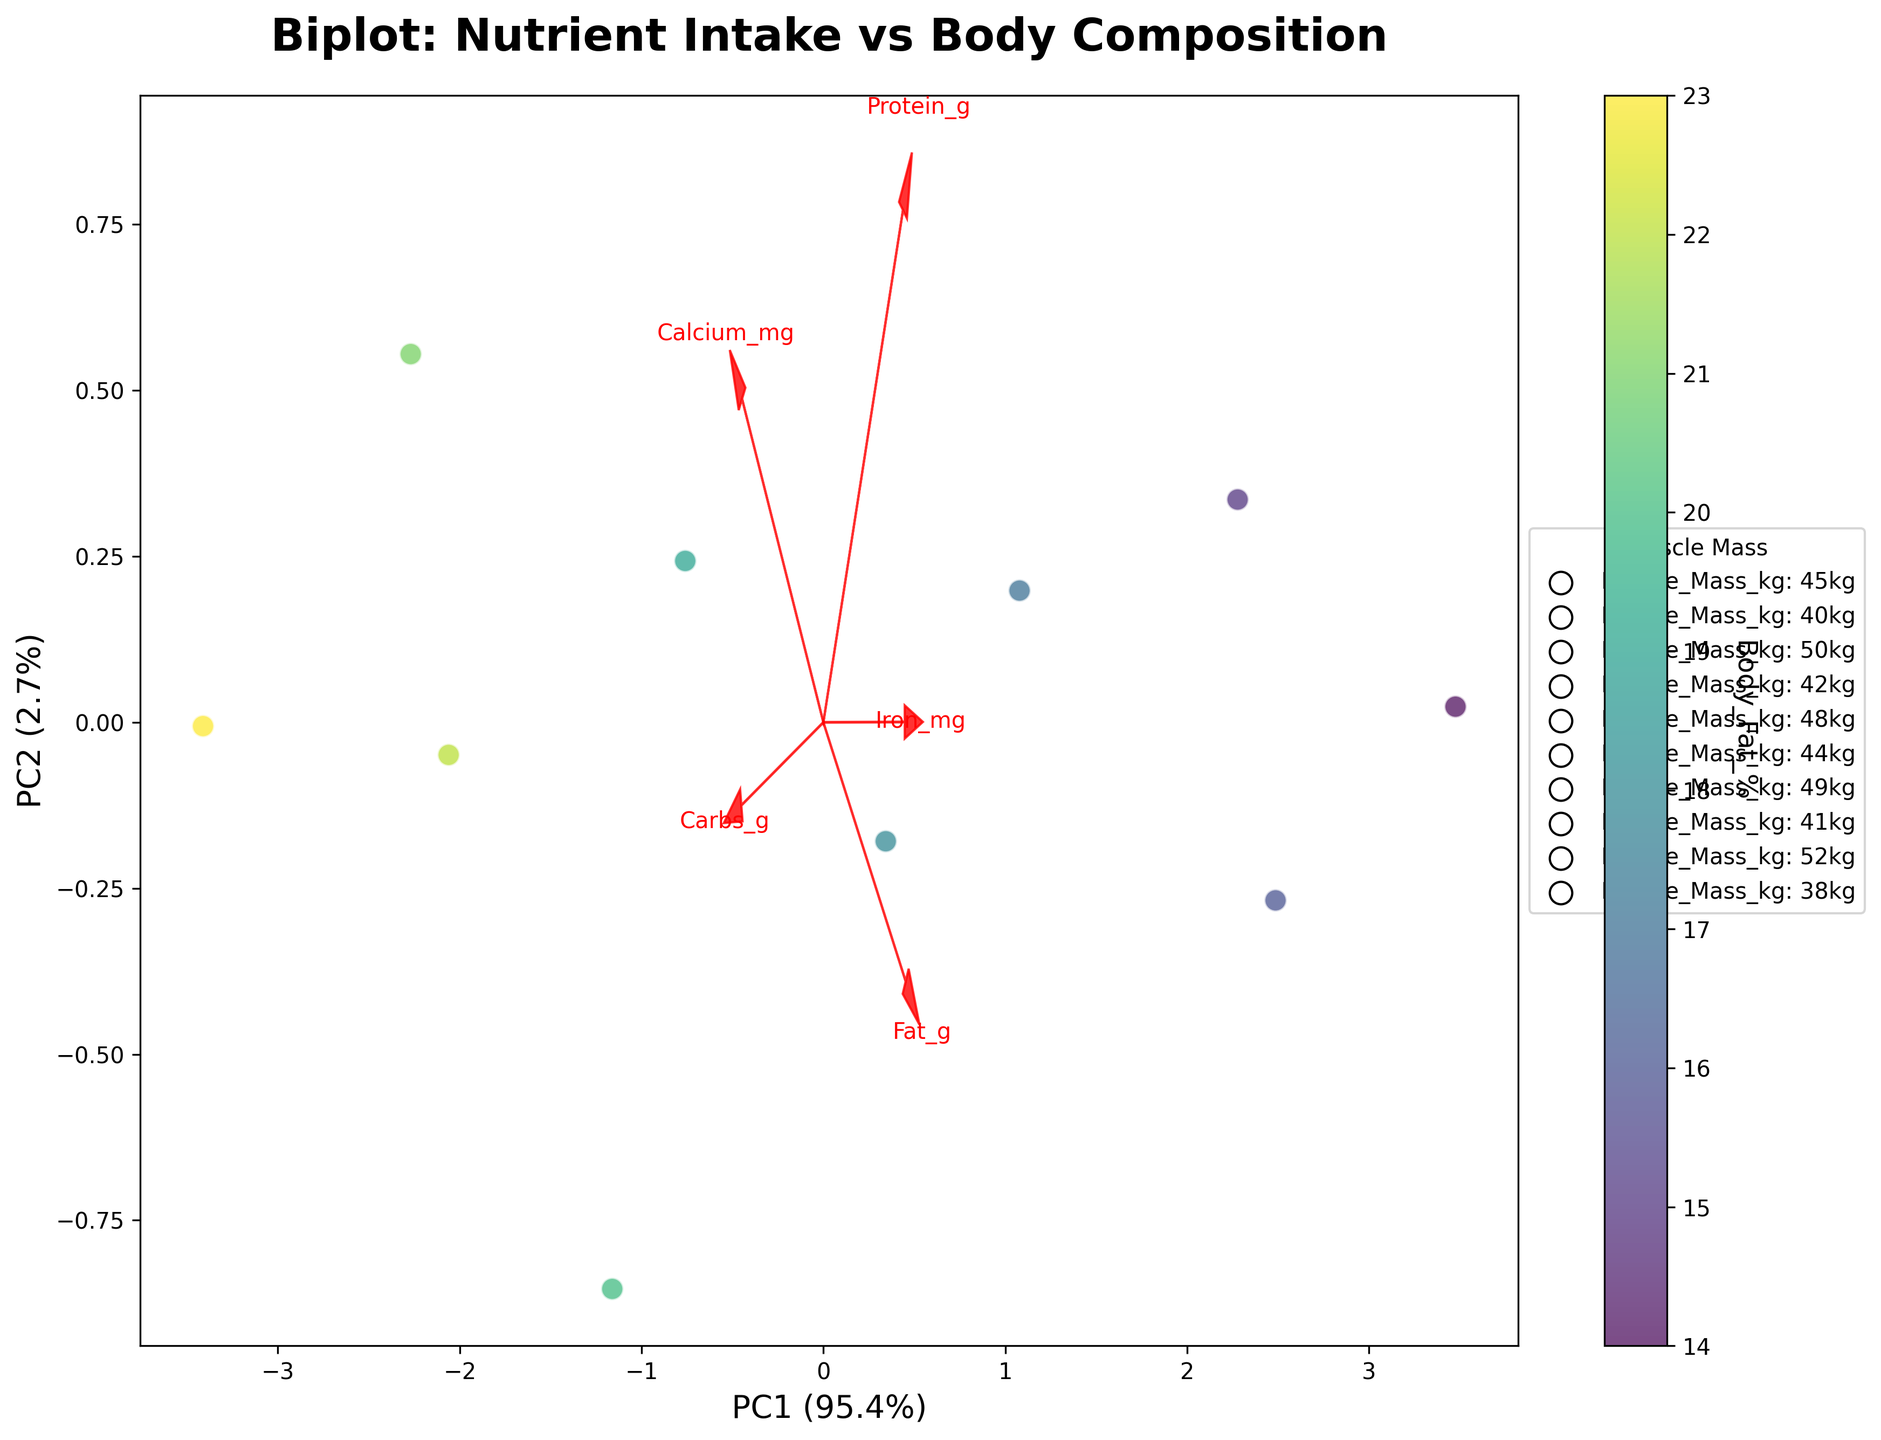What's the title of the plot? The title is situated at the top of the plot. It is "Biplot: Nutrient Intake vs Body Composition", which indicates the main focus of the figure.
Answer: Biplot: Nutrient Intake vs Body Composition What do the arrows represent in the biplot? The arrows represent the feature loadings of the original variables. They indicate the direction and magnitude of each nutrient variable with respect to the principal components. The text labels near the tips of the arrows show the names of these nutrients.
Answer: Feature loadings of nutrients Which body composition indicator is used for coloring the data points? The color bar on the right side of the plot shows that the color of the data points represents Body Fat %. The color gradient aligns with body fat percentage values.
Answer: Body Fat % How many data points are there in the plot? Each student is represented by a data point in the biplot. By counting the data points visible in the plot, there are 10 data points, corresponding to 10 students.
Answer: 10 Which nutrient appears to have the largest impact on Principal Component 1 (PC1)? To determine which nutrient has the largest impact on PC1, look at the length and direction of the arrows along the PC1 axis. 'Carbs_g' points out the furthest along PC1, suggesting it has the largest loading on PC1.
Answer: Carbs_g For the student with the highest muscle mass, what is their approximate body fat percentage? The legend indicates that the edge color of data points represents muscle mass. The student with the highest muscle mass (23 kg) corresponds to the data point with the edge color labeled in the legend. By looking at the color, we can approximate that their body fat percentage is around 22%.
Answer: 22% Which nutrient is least correlated with the second principal component (PC2)? By examining the arrows and their lengths along PC2, the nutrient whose arrow has the smallest or least extension towards the PC2 axis should be identified. 'Fat_g' has the least projection along the PC2 direction, indicating it's least correlated with PC2.
Answer: Fat_g How does the intake of Iron_mg relate to PC1 and PC2? By looking at the direction of the 'Iron_mg' arrow, we see it has a moderate positive direction along PC2 and a somewhat negative direction along PC1. This indicates that Iron_mg is positively correlated with PC2 and negatively correlated with PC1.
Answer: Positive correlation with PC2, negative correlation with PC1 